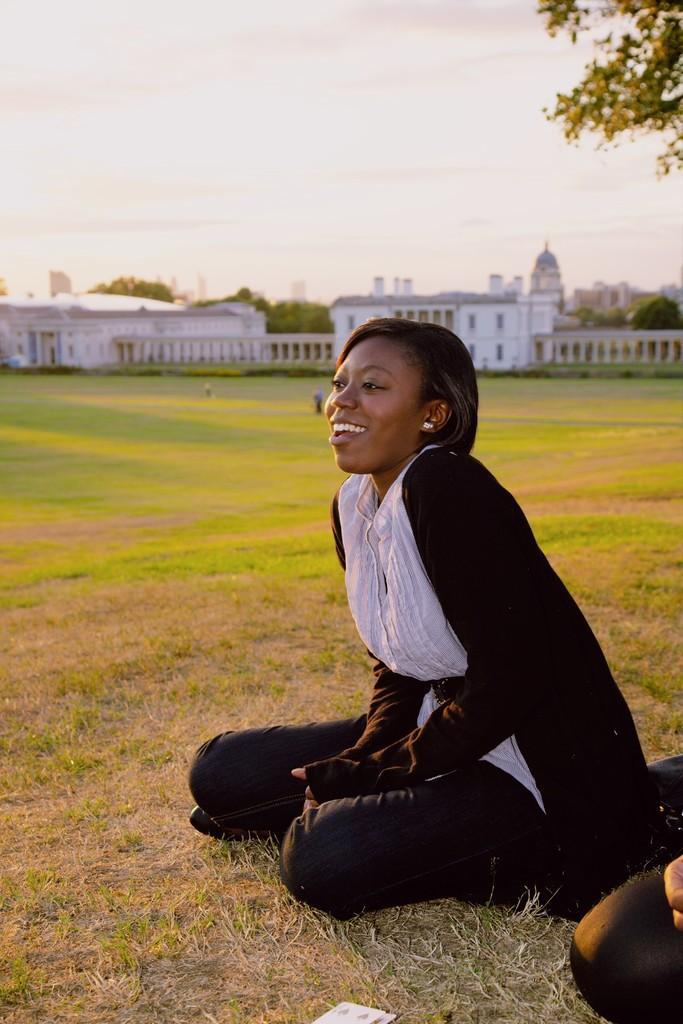Could you give a brief overview of what you see in this image? In this picture we can see a woman sitting on the ground and in the background we can see buildings, fence, trees, sky with clouds. 